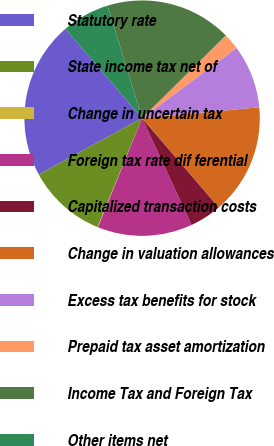Convert chart. <chart><loc_0><loc_0><loc_500><loc_500><pie_chart><fcel>Statutory rate<fcel>State income tax net of<fcel>Change in uncertain tax<fcel>Foreign tax rate dif ferential<fcel>Capitalized transaction costs<fcel>Change in valuation allowances<fcel>Excess tax benefits for stock<fcel>Prepaid tax asset amortization<fcel>Income Tax and Foreign Tax<fcel>Other items net<nl><fcel>21.66%<fcel>10.86%<fcel>0.07%<fcel>13.02%<fcel>4.39%<fcel>15.18%<fcel>8.7%<fcel>2.23%<fcel>17.34%<fcel>6.55%<nl></chart> 